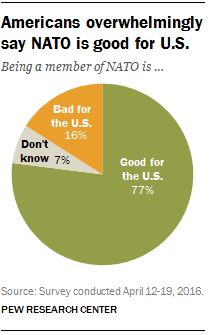Highlight a few significant elements in this photo. The value of the largest segment is 0.77. The value of the 'Don't know segment' is not equal to half the value of the 'Bad for the U.S.' segment. 